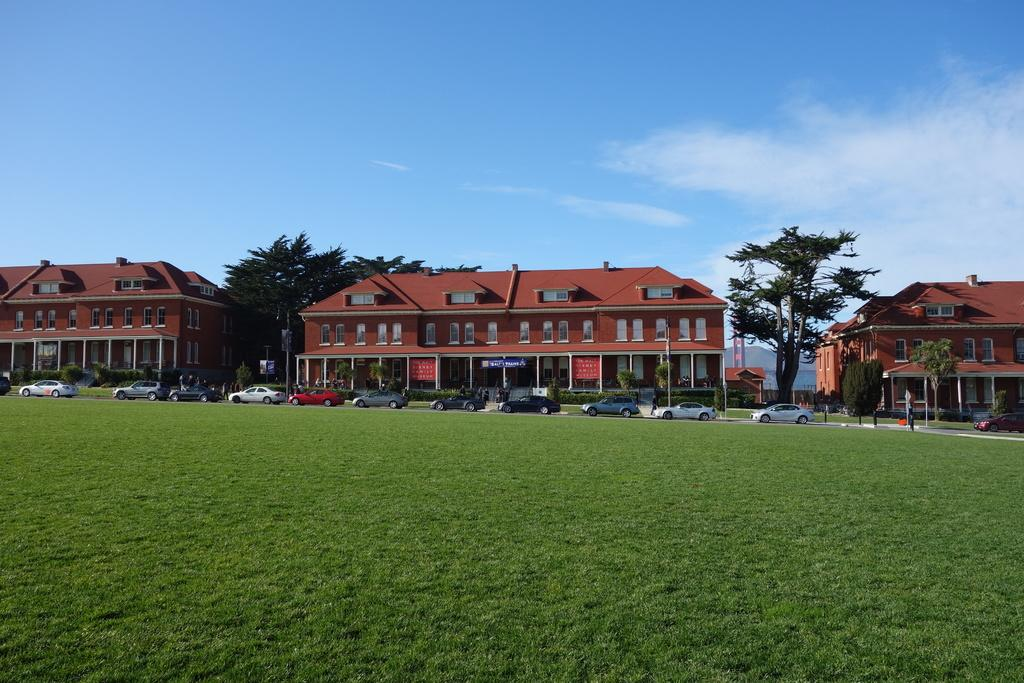What type of surface is at the bottom of the image? There is grass on the ground at the bottom of the image. What can be seen in the background of the image? There are vehicles on the road, buildings, mountains, windows, poles, banners, and hoardings in the background. What is visible in the sky in the image? Clouds are visible in the sky. How does the balloon stop in the image? There is no balloon present in the image, so it cannot stop or be stopped. 